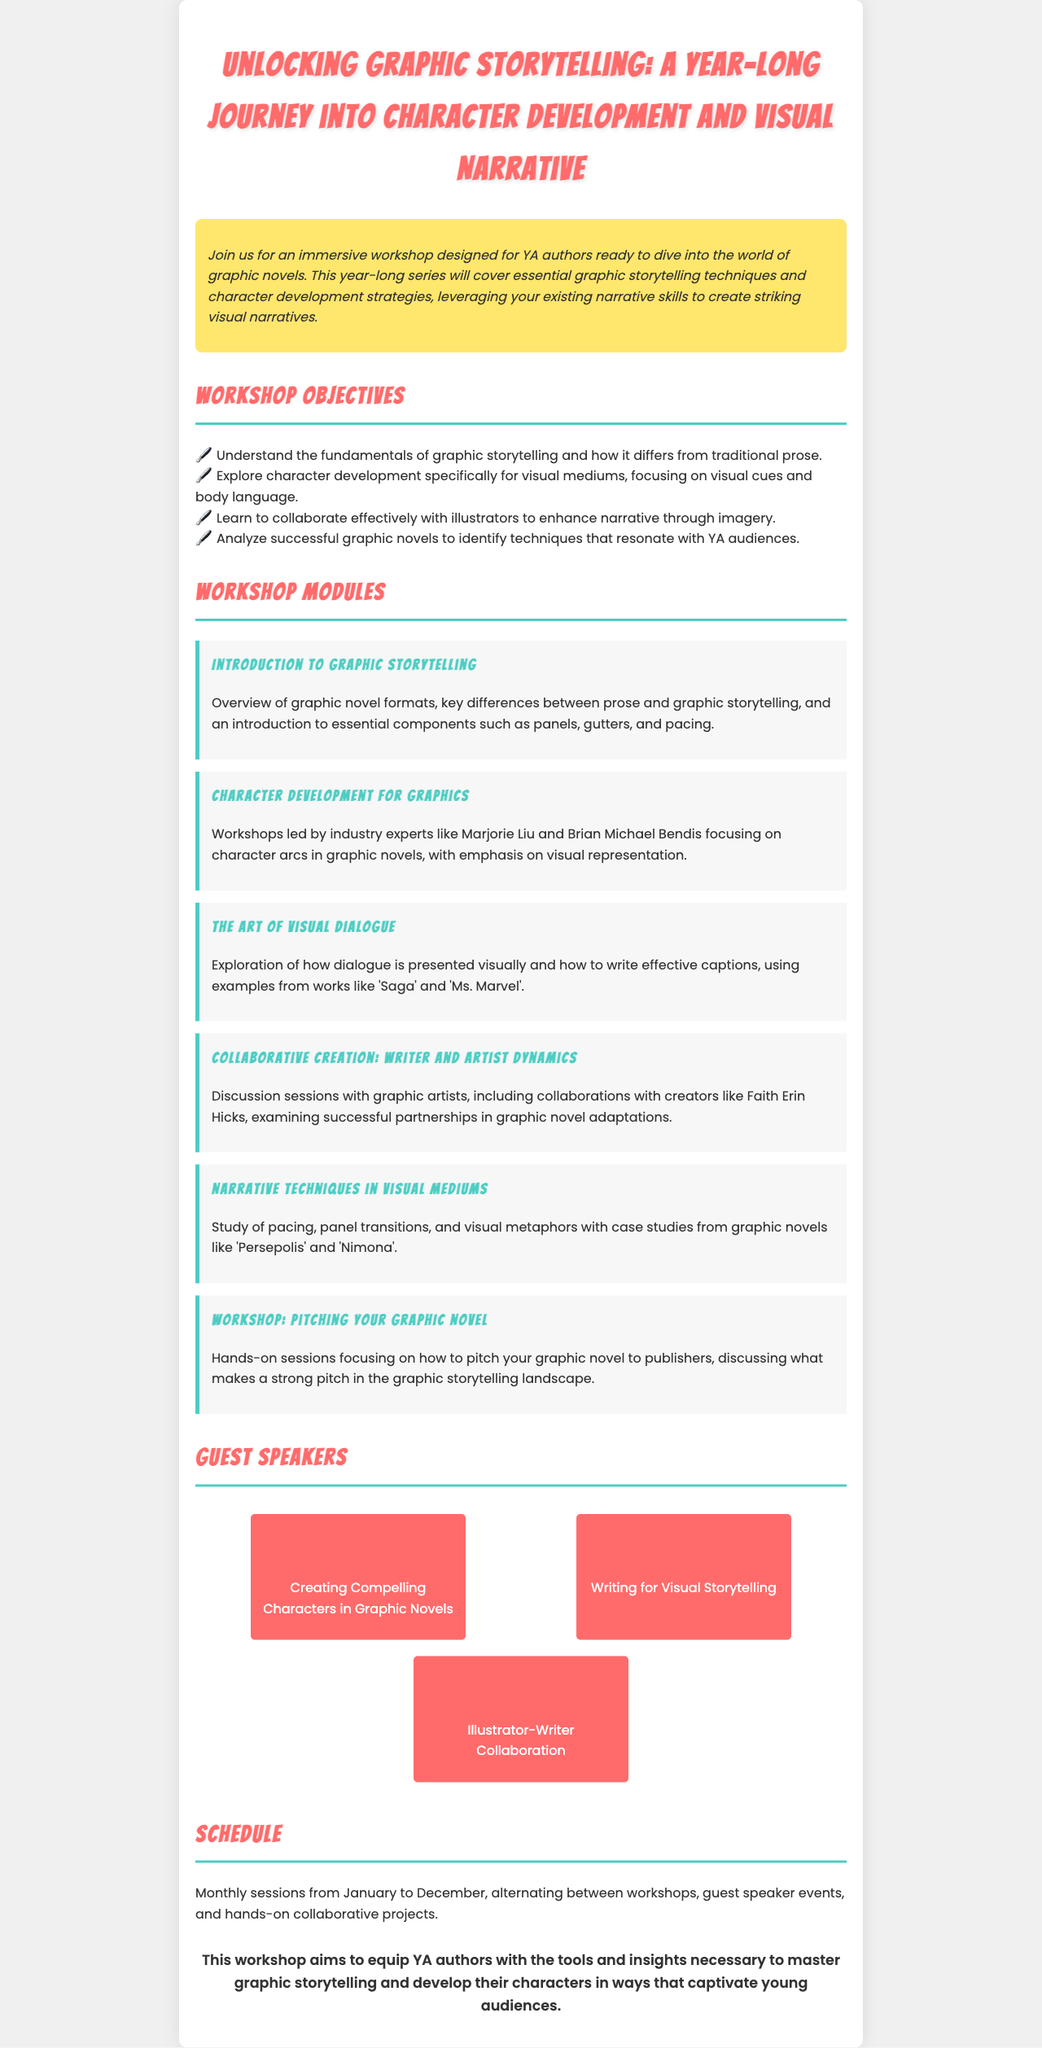What is the title of the workshop? The title is prominently displayed at the top of the document.
Answer: Unlocking Graphic Storytelling: A Year-Long Journey into Character Development and Visual Narrative Who is one of the guest speakers? The guest speakers are listed in a specific section of the document.
Answer: Marjorie Liu How many modules are included in the workshop? The document lists the individual workshop modules under a specific section.
Answer: Six What is the focus of the "Character Development for Graphics" module? The module outlines key topics covered in that specific workshop.
Answer: Character arcs in graphic novels What is the schedule for the workshop sessions? The schedule is summarized in a single statement in the document.
Answer: Monthly sessions from January to December Which graphic novels are used as case studies in the workshop? The document mentions specific graphic novels related to the content of the modules.
Answer: Persepolis and Nimona What is the primary audience for the workshop? The overview section gives insight into the intended participants of the program.
Answer: YA authors What month do the workshop sessions start? The schedule details when the sessions commence within the year.
Answer: January 